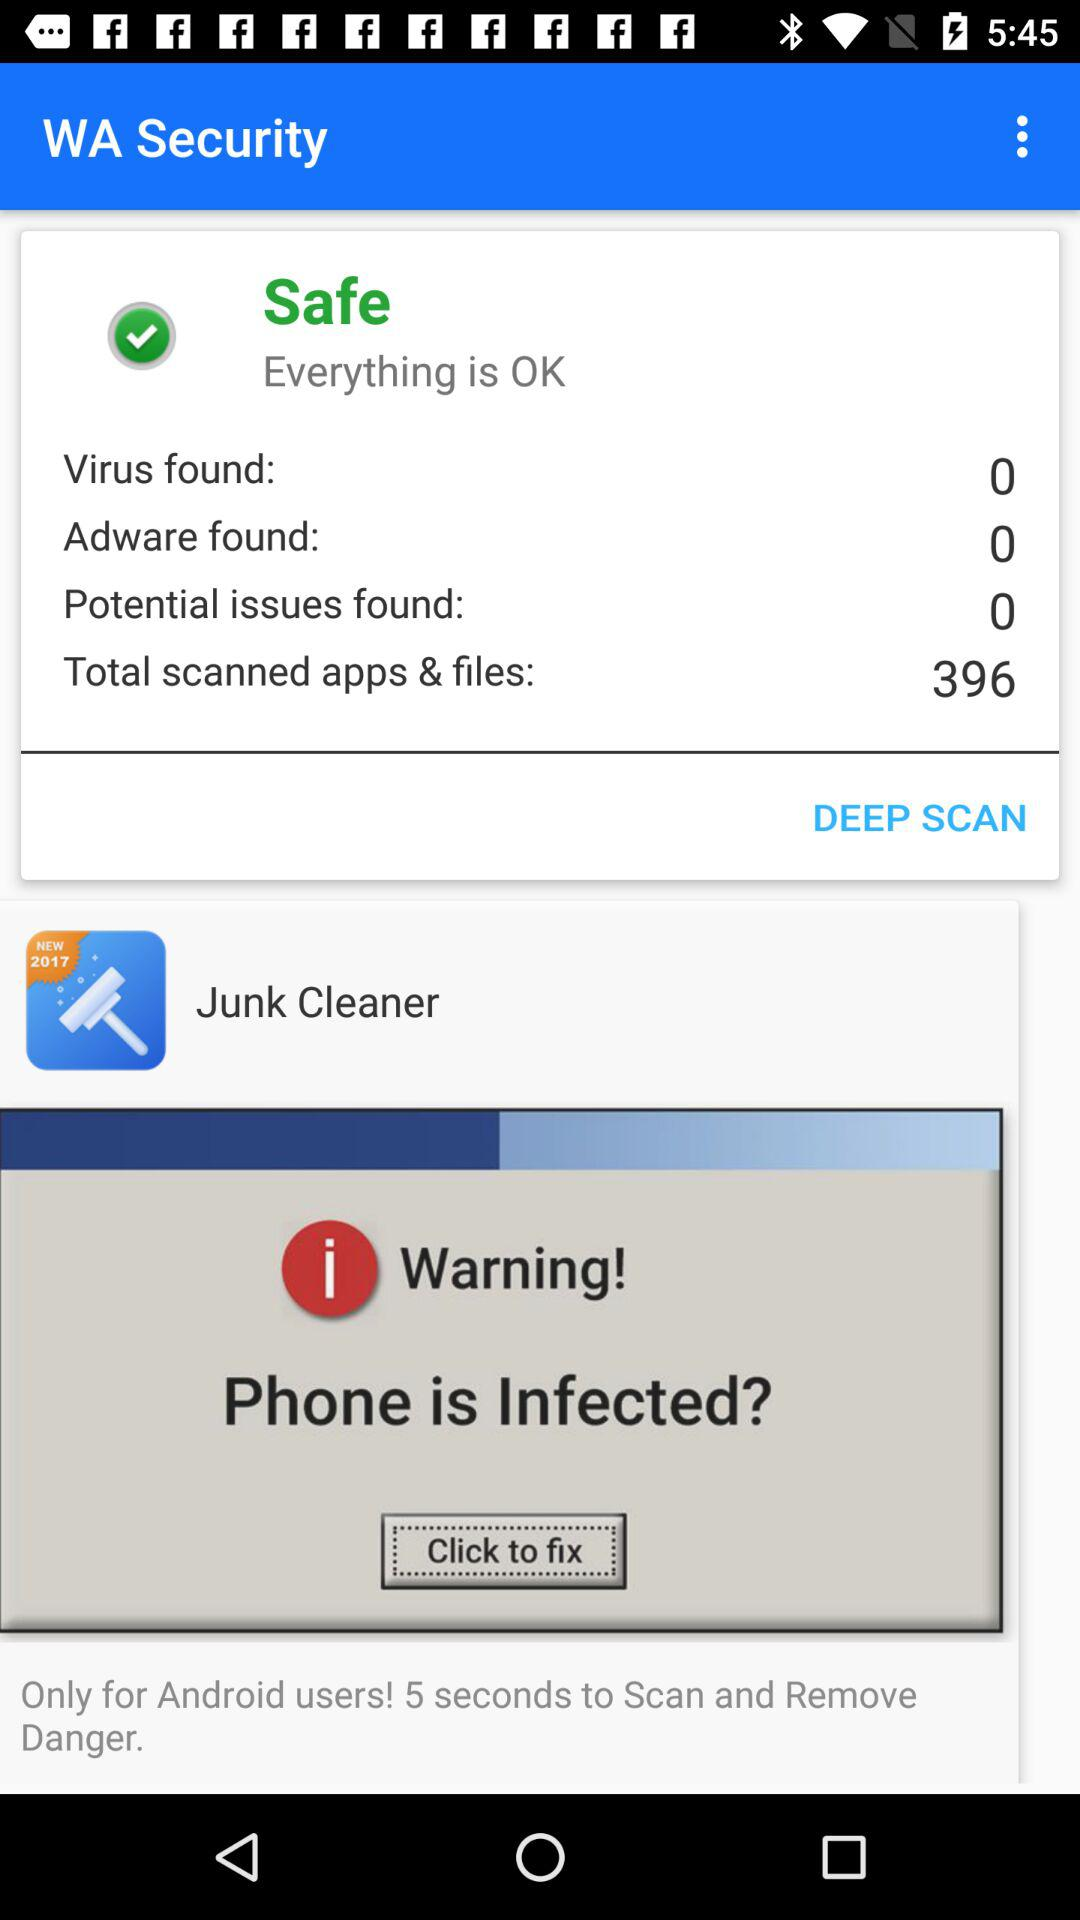How many more virus than potential issues were found?
Answer the question using a single word or phrase. 0 